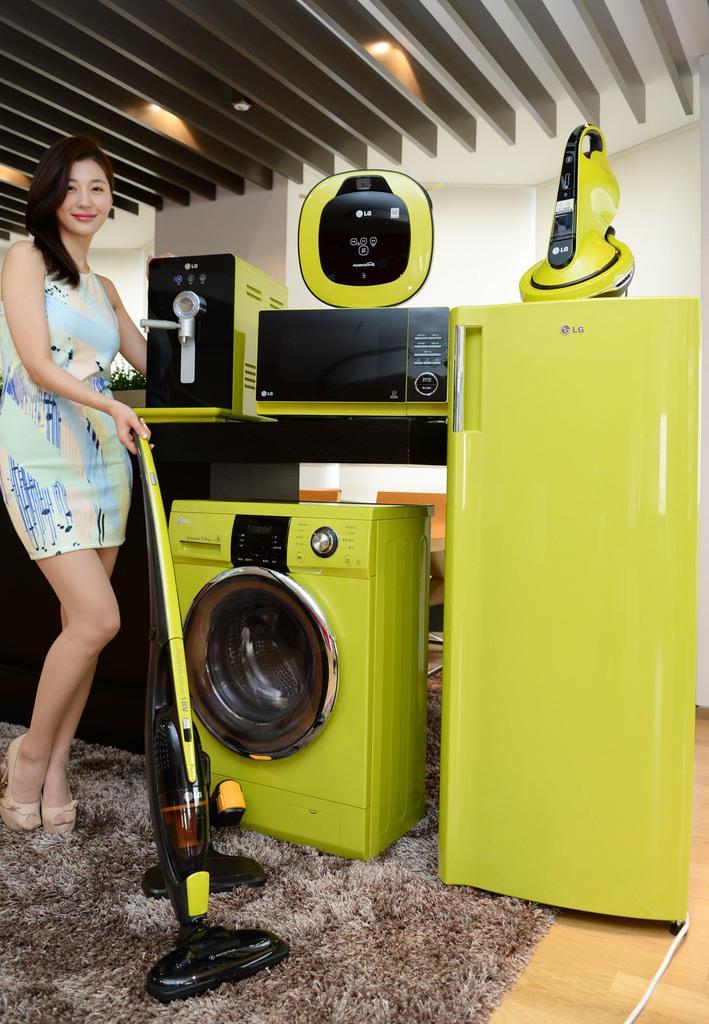Describe this image in one or two sentences. In this picture there is a lady on the left side of the image, by holding a vacuum cleaner and there is a washing machine, refrigerator and other items in the center of the image, on a rug and there is a roof at the top side of the image. 